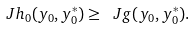Convert formula to latex. <formula><loc_0><loc_0><loc_500><loc_500>\ J h _ { 0 } ( y _ { 0 } , y _ { 0 } ^ { * } ) \geq \ J g ( y _ { 0 } , y _ { 0 } ^ { * } ) .</formula> 